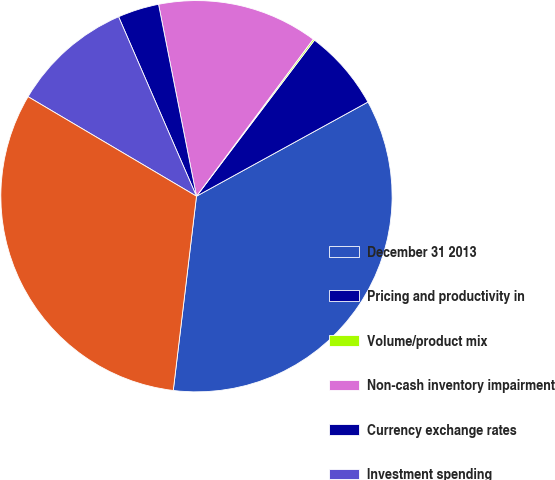Convert chart. <chart><loc_0><loc_0><loc_500><loc_500><pie_chart><fcel>December 31 2013<fcel>Pricing and productivity in<fcel>Volume/product mix<fcel>Non-cash inventory impairment<fcel>Currency exchange rates<fcel>Investment spending<fcel>December 31 2014<nl><fcel>34.89%<fcel>6.7%<fcel>0.13%<fcel>13.28%<fcel>3.41%<fcel>9.99%<fcel>31.6%<nl></chart> 